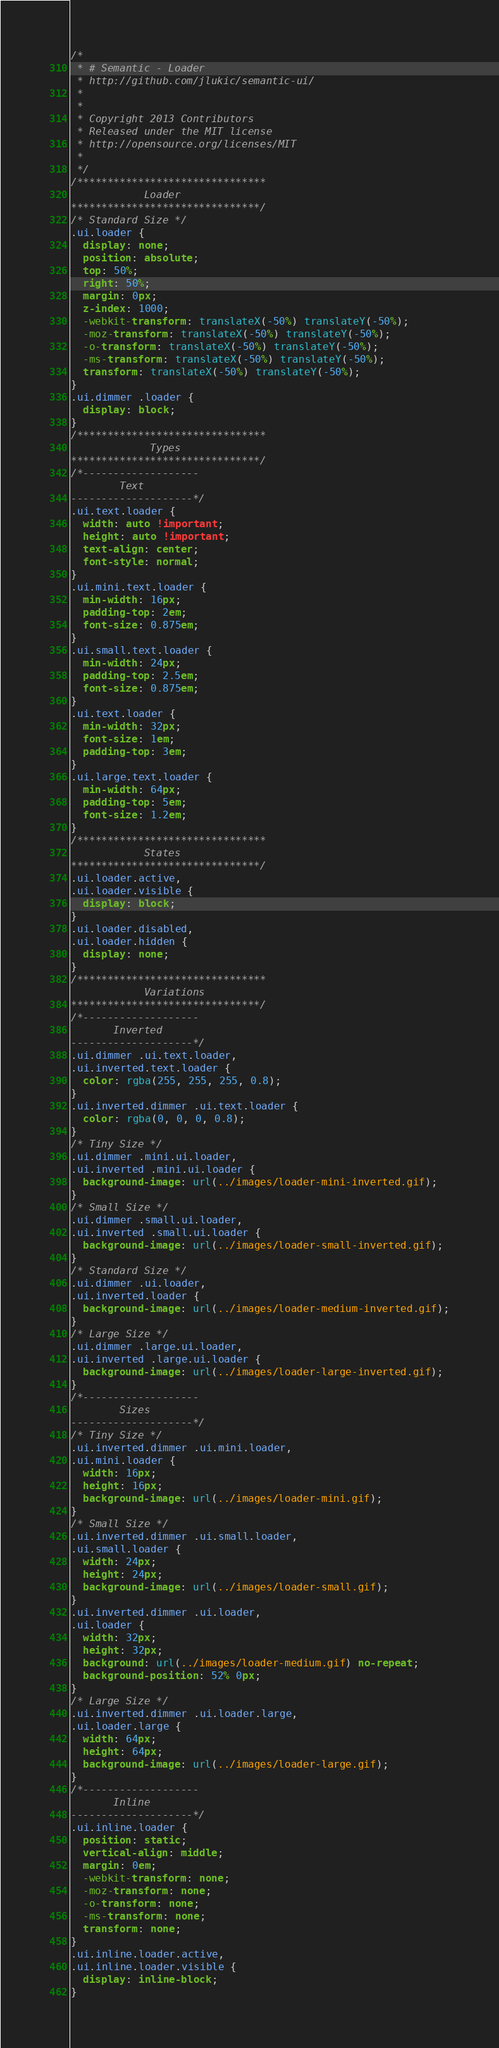Convert code to text. <code><loc_0><loc_0><loc_500><loc_500><_CSS_>/*
 * # Semantic - Loader
 * http://github.com/jlukic/semantic-ui/
 *
 *
 * Copyright 2013 Contributors
 * Released under the MIT license
 * http://opensource.org/licenses/MIT
 *
 */
/*******************************
            Loader
*******************************/
/* Standard Size */
.ui.loader {
  display: none;
  position: absolute;
  top: 50%;
  right: 50%;
  margin: 0px;
  z-index: 1000;
  -webkit-transform: translateX(-50%) translateY(-50%);
  -moz-transform: translateX(-50%) translateY(-50%);
  -o-transform: translateX(-50%) translateY(-50%);
  -ms-transform: translateX(-50%) translateY(-50%);
  transform: translateX(-50%) translateY(-50%);
}
.ui.dimmer .loader {
  display: block;
}
/*******************************
             Types
*******************************/
/*-------------------
        Text
--------------------*/
.ui.text.loader {
  width: auto !important;
  height: auto !important;
  text-align: center;
  font-style: normal;
}
.ui.mini.text.loader {
  min-width: 16px;
  padding-top: 2em;
  font-size: 0.875em;
}
.ui.small.text.loader {
  min-width: 24px;
  padding-top: 2.5em;
  font-size: 0.875em;
}
.ui.text.loader {
  min-width: 32px;
  font-size: 1em;
  padding-top: 3em;
}
.ui.large.text.loader {
  min-width: 64px;
  padding-top: 5em;
  font-size: 1.2em;
}
/*******************************
            States
*******************************/
.ui.loader.active,
.ui.loader.visible {
  display: block;
}
.ui.loader.disabled,
.ui.loader.hidden {
  display: none;
}
/*******************************
            Variations
*******************************/
/*-------------------
       Inverted
--------------------*/
.ui.dimmer .ui.text.loader,
.ui.inverted.text.loader {
  color: rgba(255, 255, 255, 0.8);
}
.ui.inverted.dimmer .ui.text.loader {
  color: rgba(0, 0, 0, 0.8);
}
/* Tiny Size */
.ui.dimmer .mini.ui.loader,
.ui.inverted .mini.ui.loader {
  background-image: url(../images/loader-mini-inverted.gif);
}
/* Small Size */
.ui.dimmer .small.ui.loader,
.ui.inverted .small.ui.loader {
  background-image: url(../images/loader-small-inverted.gif);
}
/* Standard Size */
.ui.dimmer .ui.loader,
.ui.inverted.loader {
  background-image: url(../images/loader-medium-inverted.gif);
}
/* Large Size */
.ui.dimmer .large.ui.loader,
.ui.inverted .large.ui.loader {
  background-image: url(../images/loader-large-inverted.gif);
}
/*-------------------
        Sizes
--------------------*/
/* Tiny Size */
.ui.inverted.dimmer .ui.mini.loader,
.ui.mini.loader {
  width: 16px;
  height: 16px;
  background-image: url(../images/loader-mini.gif);
}
/* Small Size */
.ui.inverted.dimmer .ui.small.loader,
.ui.small.loader {
  width: 24px;
  height: 24px;
  background-image: url(../images/loader-small.gif);
}
.ui.inverted.dimmer .ui.loader,
.ui.loader {
  width: 32px;
  height: 32px;
  background: url(../images/loader-medium.gif) no-repeat;
  background-position: 52% 0px;
}
/* Large Size */
.ui.inverted.dimmer .ui.loader.large,
.ui.loader.large {
  width: 64px;
  height: 64px;
  background-image: url(../images/loader-large.gif);
}
/*-------------------
       Inline
--------------------*/
.ui.inline.loader {
  position: static;
  vertical-align: middle;
  margin: 0em;
  -webkit-transform: none;
  -moz-transform: none;
  -o-transform: none;
  -ms-transform: none;
  transform: none;
}
.ui.inline.loader.active,
.ui.inline.loader.visible {
  display: inline-block;
}
</code> 